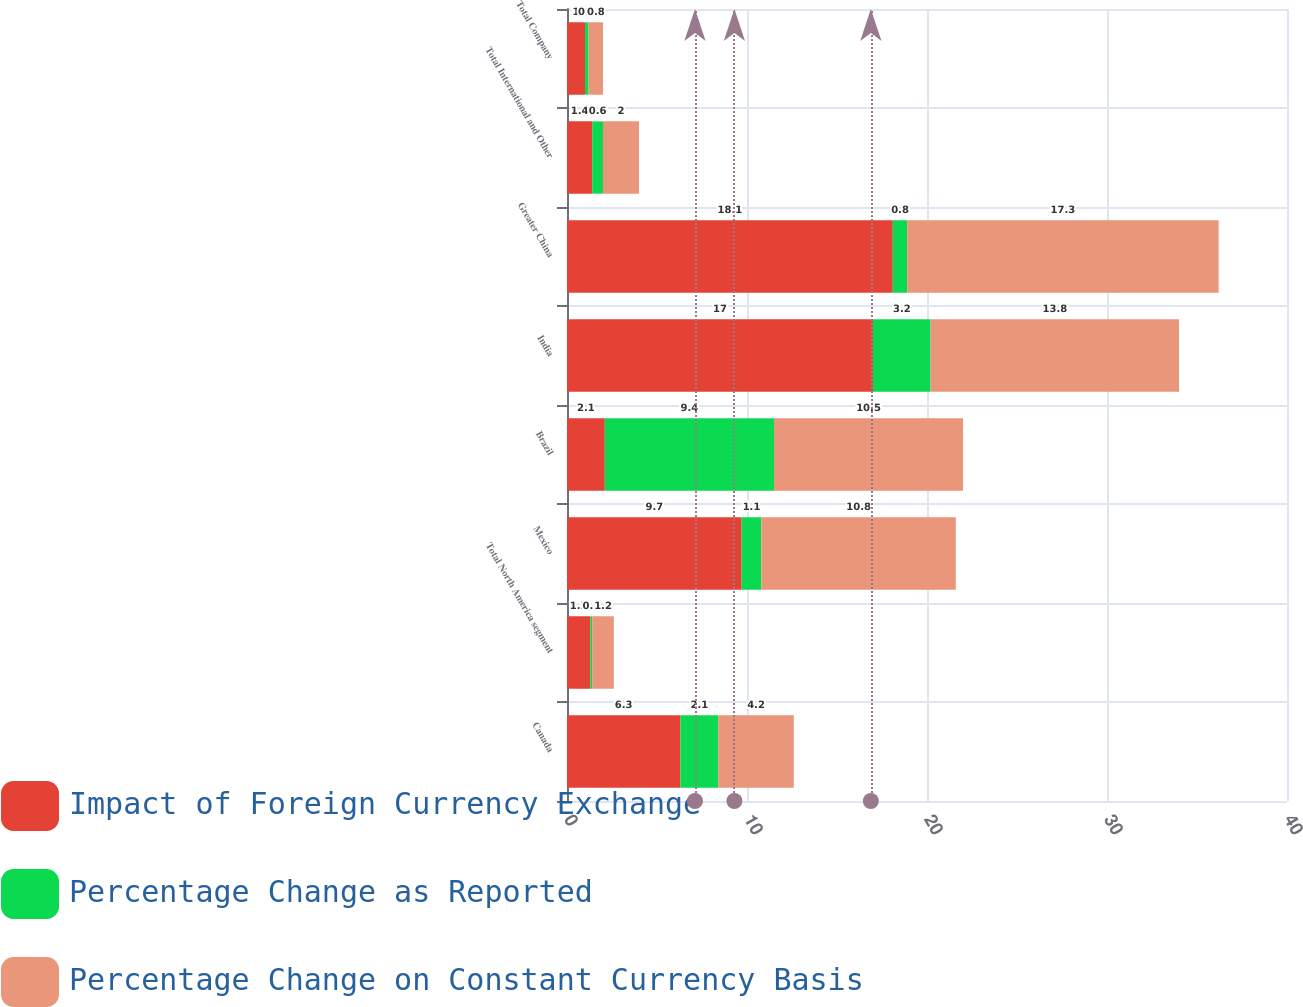Convert chart to OTSL. <chart><loc_0><loc_0><loc_500><loc_500><stacked_bar_chart><ecel><fcel>Canada<fcel>Total North America segment<fcel>Mexico<fcel>Brazil<fcel>India<fcel>Greater China<fcel>Total International and Other<fcel>Total Company<nl><fcel>Impact of Foreign Currency Exchange<fcel>6.3<fcel>1.3<fcel>9.7<fcel>2.1<fcel>17<fcel>18.1<fcel>1.4<fcel>1<nl><fcel>Percentage Change as Reported<fcel>2.1<fcel>0.1<fcel>1.1<fcel>9.4<fcel>3.2<fcel>0.8<fcel>0.6<fcel>0.2<nl><fcel>Percentage Change on Constant Currency Basis<fcel>4.2<fcel>1.2<fcel>10.8<fcel>10.5<fcel>13.8<fcel>17.3<fcel>2<fcel>0.8<nl></chart> 